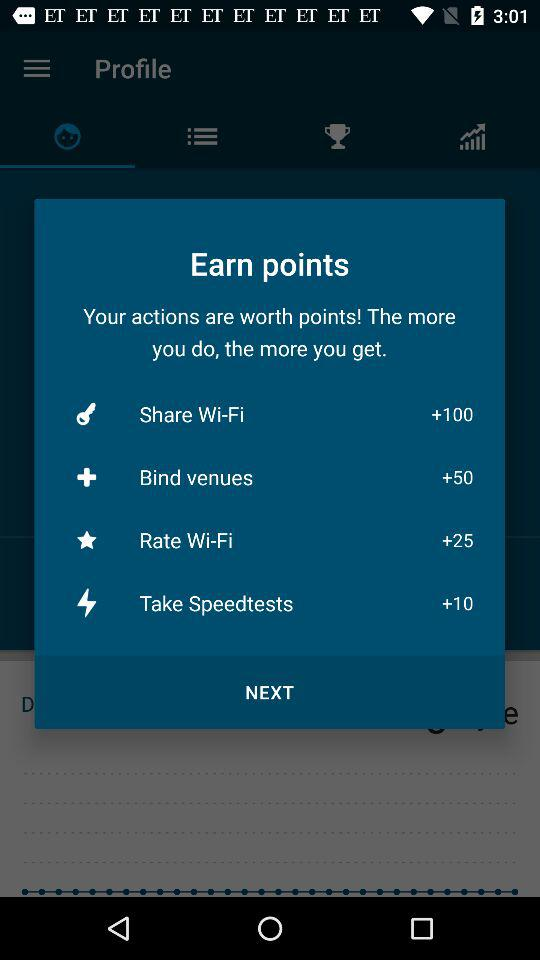How many points are offered for sharing Wi-Fi? Sharing Wi-Fi offers you the highest reward in this points system, granting you 100 points. As part of an incentive program, sharing your Wi-Fi connection is a highly valued action that contributes significantly to the total points you can earn, reflecting its importance within this particular rewards structure. 